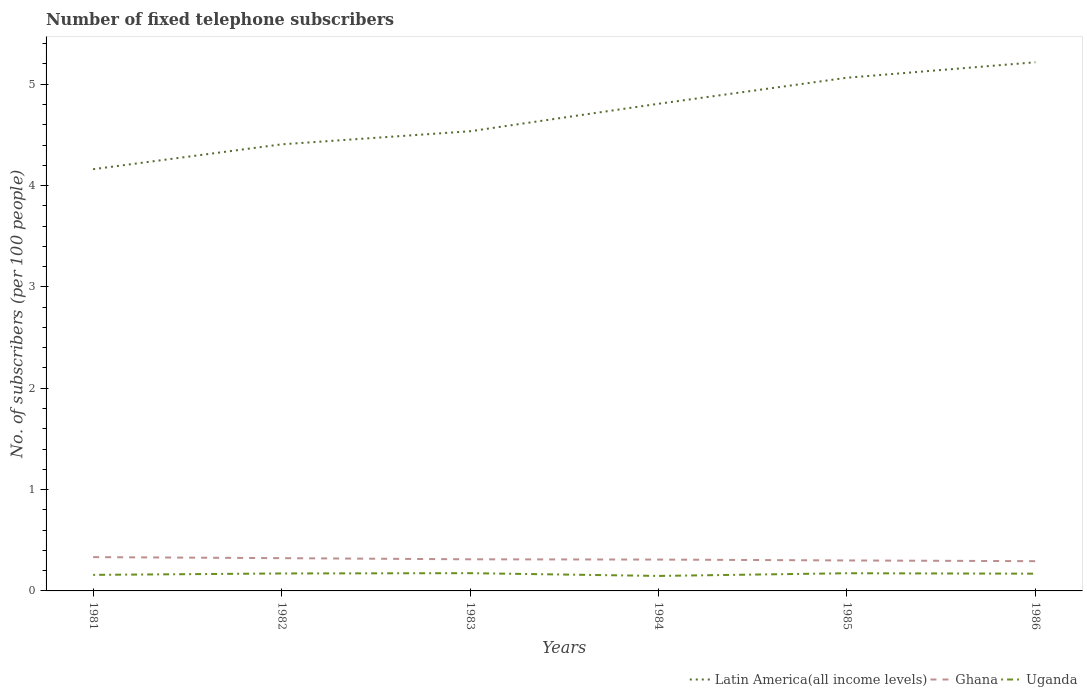Across all years, what is the maximum number of fixed telephone subscribers in Ghana?
Offer a very short reply. 0.29. In which year was the number of fixed telephone subscribers in Ghana maximum?
Make the answer very short. 1986. What is the total number of fixed telephone subscribers in Uganda in the graph?
Ensure brevity in your answer.  -0. What is the difference between the highest and the second highest number of fixed telephone subscribers in Ghana?
Offer a very short reply. 0.04. What is the difference between the highest and the lowest number of fixed telephone subscribers in Uganda?
Your response must be concise. 4. Is the number of fixed telephone subscribers in Ghana strictly greater than the number of fixed telephone subscribers in Latin America(all income levels) over the years?
Keep it short and to the point. Yes. Are the values on the major ticks of Y-axis written in scientific E-notation?
Ensure brevity in your answer.  No. Where does the legend appear in the graph?
Your answer should be compact. Bottom right. How many legend labels are there?
Offer a terse response. 3. What is the title of the graph?
Offer a terse response. Number of fixed telephone subscribers. What is the label or title of the Y-axis?
Make the answer very short. No. of subscribers (per 100 people). What is the No. of subscribers (per 100 people) in Latin America(all income levels) in 1981?
Keep it short and to the point. 4.16. What is the No. of subscribers (per 100 people) in Ghana in 1981?
Make the answer very short. 0.33. What is the No. of subscribers (per 100 people) in Uganda in 1981?
Your answer should be compact. 0.16. What is the No. of subscribers (per 100 people) of Latin America(all income levels) in 1982?
Your response must be concise. 4.41. What is the No. of subscribers (per 100 people) of Ghana in 1982?
Ensure brevity in your answer.  0.32. What is the No. of subscribers (per 100 people) of Uganda in 1982?
Give a very brief answer. 0.17. What is the No. of subscribers (per 100 people) in Latin America(all income levels) in 1983?
Offer a terse response. 4.54. What is the No. of subscribers (per 100 people) in Ghana in 1983?
Offer a very short reply. 0.31. What is the No. of subscribers (per 100 people) of Uganda in 1983?
Offer a very short reply. 0.18. What is the No. of subscribers (per 100 people) in Latin America(all income levels) in 1984?
Your answer should be compact. 4.81. What is the No. of subscribers (per 100 people) of Ghana in 1984?
Offer a very short reply. 0.31. What is the No. of subscribers (per 100 people) of Uganda in 1984?
Offer a terse response. 0.15. What is the No. of subscribers (per 100 people) in Latin America(all income levels) in 1985?
Provide a short and direct response. 5.06. What is the No. of subscribers (per 100 people) of Ghana in 1985?
Provide a short and direct response. 0.3. What is the No. of subscribers (per 100 people) of Uganda in 1985?
Your response must be concise. 0.17. What is the No. of subscribers (per 100 people) in Latin America(all income levels) in 1986?
Provide a succinct answer. 5.22. What is the No. of subscribers (per 100 people) in Ghana in 1986?
Provide a succinct answer. 0.29. What is the No. of subscribers (per 100 people) in Uganda in 1986?
Provide a short and direct response. 0.17. Across all years, what is the maximum No. of subscribers (per 100 people) of Latin America(all income levels)?
Give a very brief answer. 5.22. Across all years, what is the maximum No. of subscribers (per 100 people) of Ghana?
Give a very brief answer. 0.33. Across all years, what is the maximum No. of subscribers (per 100 people) of Uganda?
Your answer should be very brief. 0.18. Across all years, what is the minimum No. of subscribers (per 100 people) of Latin America(all income levels)?
Your response must be concise. 4.16. Across all years, what is the minimum No. of subscribers (per 100 people) of Ghana?
Your answer should be compact. 0.29. Across all years, what is the minimum No. of subscribers (per 100 people) in Uganda?
Offer a terse response. 0.15. What is the total No. of subscribers (per 100 people) of Latin America(all income levels) in the graph?
Ensure brevity in your answer.  28.19. What is the total No. of subscribers (per 100 people) in Ghana in the graph?
Your answer should be very brief. 1.87. What is the total No. of subscribers (per 100 people) in Uganda in the graph?
Ensure brevity in your answer.  1. What is the difference between the No. of subscribers (per 100 people) of Latin America(all income levels) in 1981 and that in 1982?
Your response must be concise. -0.25. What is the difference between the No. of subscribers (per 100 people) of Ghana in 1981 and that in 1982?
Provide a succinct answer. 0.01. What is the difference between the No. of subscribers (per 100 people) of Uganda in 1981 and that in 1982?
Your answer should be compact. -0.01. What is the difference between the No. of subscribers (per 100 people) of Latin America(all income levels) in 1981 and that in 1983?
Offer a terse response. -0.37. What is the difference between the No. of subscribers (per 100 people) of Ghana in 1981 and that in 1983?
Ensure brevity in your answer.  0.02. What is the difference between the No. of subscribers (per 100 people) of Uganda in 1981 and that in 1983?
Give a very brief answer. -0.02. What is the difference between the No. of subscribers (per 100 people) of Latin America(all income levels) in 1981 and that in 1984?
Provide a succinct answer. -0.65. What is the difference between the No. of subscribers (per 100 people) in Ghana in 1981 and that in 1984?
Provide a short and direct response. 0.02. What is the difference between the No. of subscribers (per 100 people) in Uganda in 1981 and that in 1984?
Provide a succinct answer. 0.01. What is the difference between the No. of subscribers (per 100 people) in Latin America(all income levels) in 1981 and that in 1985?
Provide a succinct answer. -0.9. What is the difference between the No. of subscribers (per 100 people) in Ghana in 1981 and that in 1985?
Give a very brief answer. 0.03. What is the difference between the No. of subscribers (per 100 people) of Uganda in 1981 and that in 1985?
Make the answer very short. -0.02. What is the difference between the No. of subscribers (per 100 people) of Latin America(all income levels) in 1981 and that in 1986?
Provide a short and direct response. -1.06. What is the difference between the No. of subscribers (per 100 people) of Ghana in 1981 and that in 1986?
Give a very brief answer. 0.04. What is the difference between the No. of subscribers (per 100 people) of Uganda in 1981 and that in 1986?
Provide a short and direct response. -0.01. What is the difference between the No. of subscribers (per 100 people) in Latin America(all income levels) in 1982 and that in 1983?
Your answer should be very brief. -0.13. What is the difference between the No. of subscribers (per 100 people) of Ghana in 1982 and that in 1983?
Provide a succinct answer. 0.01. What is the difference between the No. of subscribers (per 100 people) of Uganda in 1982 and that in 1983?
Make the answer very short. -0. What is the difference between the No. of subscribers (per 100 people) of Latin America(all income levels) in 1982 and that in 1984?
Your response must be concise. -0.4. What is the difference between the No. of subscribers (per 100 people) of Ghana in 1982 and that in 1984?
Offer a terse response. 0.01. What is the difference between the No. of subscribers (per 100 people) in Uganda in 1982 and that in 1984?
Ensure brevity in your answer.  0.02. What is the difference between the No. of subscribers (per 100 people) of Latin America(all income levels) in 1982 and that in 1985?
Provide a short and direct response. -0.66. What is the difference between the No. of subscribers (per 100 people) in Ghana in 1982 and that in 1985?
Keep it short and to the point. 0.02. What is the difference between the No. of subscribers (per 100 people) of Uganda in 1982 and that in 1985?
Ensure brevity in your answer.  -0. What is the difference between the No. of subscribers (per 100 people) in Latin America(all income levels) in 1982 and that in 1986?
Your answer should be very brief. -0.81. What is the difference between the No. of subscribers (per 100 people) of Ghana in 1982 and that in 1986?
Your answer should be very brief. 0.03. What is the difference between the No. of subscribers (per 100 people) in Uganda in 1982 and that in 1986?
Your answer should be very brief. 0. What is the difference between the No. of subscribers (per 100 people) of Latin America(all income levels) in 1983 and that in 1984?
Give a very brief answer. -0.27. What is the difference between the No. of subscribers (per 100 people) of Ghana in 1983 and that in 1984?
Offer a terse response. 0. What is the difference between the No. of subscribers (per 100 people) of Uganda in 1983 and that in 1984?
Offer a terse response. 0.03. What is the difference between the No. of subscribers (per 100 people) of Latin America(all income levels) in 1983 and that in 1985?
Your answer should be very brief. -0.53. What is the difference between the No. of subscribers (per 100 people) of Ghana in 1983 and that in 1985?
Your answer should be very brief. 0.01. What is the difference between the No. of subscribers (per 100 people) of Uganda in 1983 and that in 1985?
Provide a short and direct response. 0. What is the difference between the No. of subscribers (per 100 people) of Latin America(all income levels) in 1983 and that in 1986?
Ensure brevity in your answer.  -0.68. What is the difference between the No. of subscribers (per 100 people) of Ghana in 1983 and that in 1986?
Provide a short and direct response. 0.02. What is the difference between the No. of subscribers (per 100 people) of Uganda in 1983 and that in 1986?
Offer a very short reply. 0.01. What is the difference between the No. of subscribers (per 100 people) in Latin America(all income levels) in 1984 and that in 1985?
Make the answer very short. -0.26. What is the difference between the No. of subscribers (per 100 people) in Ghana in 1984 and that in 1985?
Give a very brief answer. 0.01. What is the difference between the No. of subscribers (per 100 people) in Uganda in 1984 and that in 1985?
Offer a terse response. -0.03. What is the difference between the No. of subscribers (per 100 people) in Latin America(all income levels) in 1984 and that in 1986?
Provide a short and direct response. -0.41. What is the difference between the No. of subscribers (per 100 people) of Ghana in 1984 and that in 1986?
Offer a very short reply. 0.02. What is the difference between the No. of subscribers (per 100 people) of Uganda in 1984 and that in 1986?
Offer a terse response. -0.02. What is the difference between the No. of subscribers (per 100 people) of Latin America(all income levels) in 1985 and that in 1986?
Keep it short and to the point. -0.15. What is the difference between the No. of subscribers (per 100 people) of Ghana in 1985 and that in 1986?
Offer a terse response. 0.01. What is the difference between the No. of subscribers (per 100 people) of Uganda in 1985 and that in 1986?
Your response must be concise. 0. What is the difference between the No. of subscribers (per 100 people) in Latin America(all income levels) in 1981 and the No. of subscribers (per 100 people) in Ghana in 1982?
Your answer should be compact. 3.84. What is the difference between the No. of subscribers (per 100 people) of Latin America(all income levels) in 1981 and the No. of subscribers (per 100 people) of Uganda in 1982?
Your answer should be compact. 3.99. What is the difference between the No. of subscribers (per 100 people) in Ghana in 1981 and the No. of subscribers (per 100 people) in Uganda in 1982?
Make the answer very short. 0.16. What is the difference between the No. of subscribers (per 100 people) in Latin America(all income levels) in 1981 and the No. of subscribers (per 100 people) in Ghana in 1983?
Keep it short and to the point. 3.85. What is the difference between the No. of subscribers (per 100 people) in Latin America(all income levels) in 1981 and the No. of subscribers (per 100 people) in Uganda in 1983?
Your answer should be very brief. 3.99. What is the difference between the No. of subscribers (per 100 people) of Ghana in 1981 and the No. of subscribers (per 100 people) of Uganda in 1983?
Provide a short and direct response. 0.16. What is the difference between the No. of subscribers (per 100 people) of Latin America(all income levels) in 1981 and the No. of subscribers (per 100 people) of Ghana in 1984?
Your answer should be very brief. 3.85. What is the difference between the No. of subscribers (per 100 people) of Latin America(all income levels) in 1981 and the No. of subscribers (per 100 people) of Uganda in 1984?
Offer a terse response. 4.01. What is the difference between the No. of subscribers (per 100 people) of Ghana in 1981 and the No. of subscribers (per 100 people) of Uganda in 1984?
Your answer should be very brief. 0.19. What is the difference between the No. of subscribers (per 100 people) in Latin America(all income levels) in 1981 and the No. of subscribers (per 100 people) in Ghana in 1985?
Your answer should be compact. 3.86. What is the difference between the No. of subscribers (per 100 people) of Latin America(all income levels) in 1981 and the No. of subscribers (per 100 people) of Uganda in 1985?
Your answer should be very brief. 3.99. What is the difference between the No. of subscribers (per 100 people) of Ghana in 1981 and the No. of subscribers (per 100 people) of Uganda in 1985?
Give a very brief answer. 0.16. What is the difference between the No. of subscribers (per 100 people) in Latin America(all income levels) in 1981 and the No. of subscribers (per 100 people) in Ghana in 1986?
Ensure brevity in your answer.  3.87. What is the difference between the No. of subscribers (per 100 people) in Latin America(all income levels) in 1981 and the No. of subscribers (per 100 people) in Uganda in 1986?
Give a very brief answer. 3.99. What is the difference between the No. of subscribers (per 100 people) of Ghana in 1981 and the No. of subscribers (per 100 people) of Uganda in 1986?
Keep it short and to the point. 0.16. What is the difference between the No. of subscribers (per 100 people) in Latin America(all income levels) in 1982 and the No. of subscribers (per 100 people) in Ghana in 1983?
Keep it short and to the point. 4.09. What is the difference between the No. of subscribers (per 100 people) of Latin America(all income levels) in 1982 and the No. of subscribers (per 100 people) of Uganda in 1983?
Your response must be concise. 4.23. What is the difference between the No. of subscribers (per 100 people) of Ghana in 1982 and the No. of subscribers (per 100 people) of Uganda in 1983?
Offer a very short reply. 0.15. What is the difference between the No. of subscribers (per 100 people) in Latin America(all income levels) in 1982 and the No. of subscribers (per 100 people) in Ghana in 1984?
Offer a terse response. 4.1. What is the difference between the No. of subscribers (per 100 people) of Latin America(all income levels) in 1982 and the No. of subscribers (per 100 people) of Uganda in 1984?
Give a very brief answer. 4.26. What is the difference between the No. of subscribers (per 100 people) in Ghana in 1982 and the No. of subscribers (per 100 people) in Uganda in 1984?
Offer a very short reply. 0.18. What is the difference between the No. of subscribers (per 100 people) of Latin America(all income levels) in 1982 and the No. of subscribers (per 100 people) of Ghana in 1985?
Offer a terse response. 4.11. What is the difference between the No. of subscribers (per 100 people) of Latin America(all income levels) in 1982 and the No. of subscribers (per 100 people) of Uganda in 1985?
Keep it short and to the point. 4.23. What is the difference between the No. of subscribers (per 100 people) of Ghana in 1982 and the No. of subscribers (per 100 people) of Uganda in 1985?
Provide a short and direct response. 0.15. What is the difference between the No. of subscribers (per 100 people) of Latin America(all income levels) in 1982 and the No. of subscribers (per 100 people) of Ghana in 1986?
Your response must be concise. 4.11. What is the difference between the No. of subscribers (per 100 people) of Latin America(all income levels) in 1982 and the No. of subscribers (per 100 people) of Uganda in 1986?
Your response must be concise. 4.24. What is the difference between the No. of subscribers (per 100 people) in Ghana in 1982 and the No. of subscribers (per 100 people) in Uganda in 1986?
Make the answer very short. 0.15. What is the difference between the No. of subscribers (per 100 people) of Latin America(all income levels) in 1983 and the No. of subscribers (per 100 people) of Ghana in 1984?
Give a very brief answer. 4.23. What is the difference between the No. of subscribers (per 100 people) in Latin America(all income levels) in 1983 and the No. of subscribers (per 100 people) in Uganda in 1984?
Provide a short and direct response. 4.39. What is the difference between the No. of subscribers (per 100 people) in Ghana in 1983 and the No. of subscribers (per 100 people) in Uganda in 1984?
Keep it short and to the point. 0.16. What is the difference between the No. of subscribers (per 100 people) of Latin America(all income levels) in 1983 and the No. of subscribers (per 100 people) of Ghana in 1985?
Provide a short and direct response. 4.24. What is the difference between the No. of subscribers (per 100 people) in Latin America(all income levels) in 1983 and the No. of subscribers (per 100 people) in Uganda in 1985?
Give a very brief answer. 4.36. What is the difference between the No. of subscribers (per 100 people) of Ghana in 1983 and the No. of subscribers (per 100 people) of Uganda in 1985?
Ensure brevity in your answer.  0.14. What is the difference between the No. of subscribers (per 100 people) of Latin America(all income levels) in 1983 and the No. of subscribers (per 100 people) of Ghana in 1986?
Your answer should be compact. 4.24. What is the difference between the No. of subscribers (per 100 people) in Latin America(all income levels) in 1983 and the No. of subscribers (per 100 people) in Uganda in 1986?
Offer a terse response. 4.37. What is the difference between the No. of subscribers (per 100 people) in Ghana in 1983 and the No. of subscribers (per 100 people) in Uganda in 1986?
Make the answer very short. 0.14. What is the difference between the No. of subscribers (per 100 people) in Latin America(all income levels) in 1984 and the No. of subscribers (per 100 people) in Ghana in 1985?
Make the answer very short. 4.51. What is the difference between the No. of subscribers (per 100 people) of Latin America(all income levels) in 1984 and the No. of subscribers (per 100 people) of Uganda in 1985?
Give a very brief answer. 4.63. What is the difference between the No. of subscribers (per 100 people) of Ghana in 1984 and the No. of subscribers (per 100 people) of Uganda in 1985?
Offer a terse response. 0.14. What is the difference between the No. of subscribers (per 100 people) of Latin America(all income levels) in 1984 and the No. of subscribers (per 100 people) of Ghana in 1986?
Your answer should be very brief. 4.51. What is the difference between the No. of subscribers (per 100 people) in Latin America(all income levels) in 1984 and the No. of subscribers (per 100 people) in Uganda in 1986?
Keep it short and to the point. 4.64. What is the difference between the No. of subscribers (per 100 people) in Ghana in 1984 and the No. of subscribers (per 100 people) in Uganda in 1986?
Keep it short and to the point. 0.14. What is the difference between the No. of subscribers (per 100 people) in Latin America(all income levels) in 1985 and the No. of subscribers (per 100 people) in Ghana in 1986?
Keep it short and to the point. 4.77. What is the difference between the No. of subscribers (per 100 people) of Latin America(all income levels) in 1985 and the No. of subscribers (per 100 people) of Uganda in 1986?
Ensure brevity in your answer.  4.89. What is the difference between the No. of subscribers (per 100 people) of Ghana in 1985 and the No. of subscribers (per 100 people) of Uganda in 1986?
Keep it short and to the point. 0.13. What is the average No. of subscribers (per 100 people) in Latin America(all income levels) per year?
Your response must be concise. 4.7. What is the average No. of subscribers (per 100 people) in Ghana per year?
Your response must be concise. 0.31. What is the average No. of subscribers (per 100 people) of Uganda per year?
Provide a succinct answer. 0.17. In the year 1981, what is the difference between the No. of subscribers (per 100 people) of Latin America(all income levels) and No. of subscribers (per 100 people) of Ghana?
Your answer should be very brief. 3.83. In the year 1981, what is the difference between the No. of subscribers (per 100 people) in Latin America(all income levels) and No. of subscribers (per 100 people) in Uganda?
Keep it short and to the point. 4. In the year 1981, what is the difference between the No. of subscribers (per 100 people) in Ghana and No. of subscribers (per 100 people) in Uganda?
Your answer should be compact. 0.18. In the year 1982, what is the difference between the No. of subscribers (per 100 people) of Latin America(all income levels) and No. of subscribers (per 100 people) of Ghana?
Your response must be concise. 4.08. In the year 1982, what is the difference between the No. of subscribers (per 100 people) of Latin America(all income levels) and No. of subscribers (per 100 people) of Uganda?
Ensure brevity in your answer.  4.23. In the year 1982, what is the difference between the No. of subscribers (per 100 people) of Ghana and No. of subscribers (per 100 people) of Uganda?
Offer a terse response. 0.15. In the year 1983, what is the difference between the No. of subscribers (per 100 people) of Latin America(all income levels) and No. of subscribers (per 100 people) of Ghana?
Provide a succinct answer. 4.22. In the year 1983, what is the difference between the No. of subscribers (per 100 people) in Latin America(all income levels) and No. of subscribers (per 100 people) in Uganda?
Give a very brief answer. 4.36. In the year 1983, what is the difference between the No. of subscribers (per 100 people) of Ghana and No. of subscribers (per 100 people) of Uganda?
Provide a short and direct response. 0.14. In the year 1984, what is the difference between the No. of subscribers (per 100 people) in Latin America(all income levels) and No. of subscribers (per 100 people) in Ghana?
Keep it short and to the point. 4.5. In the year 1984, what is the difference between the No. of subscribers (per 100 people) of Latin America(all income levels) and No. of subscribers (per 100 people) of Uganda?
Provide a short and direct response. 4.66. In the year 1984, what is the difference between the No. of subscribers (per 100 people) in Ghana and No. of subscribers (per 100 people) in Uganda?
Offer a very short reply. 0.16. In the year 1985, what is the difference between the No. of subscribers (per 100 people) in Latin America(all income levels) and No. of subscribers (per 100 people) in Ghana?
Offer a very short reply. 4.76. In the year 1985, what is the difference between the No. of subscribers (per 100 people) of Latin America(all income levels) and No. of subscribers (per 100 people) of Uganda?
Offer a very short reply. 4.89. In the year 1985, what is the difference between the No. of subscribers (per 100 people) in Ghana and No. of subscribers (per 100 people) in Uganda?
Make the answer very short. 0.13. In the year 1986, what is the difference between the No. of subscribers (per 100 people) of Latin America(all income levels) and No. of subscribers (per 100 people) of Ghana?
Ensure brevity in your answer.  4.92. In the year 1986, what is the difference between the No. of subscribers (per 100 people) of Latin America(all income levels) and No. of subscribers (per 100 people) of Uganda?
Your answer should be very brief. 5.05. In the year 1986, what is the difference between the No. of subscribers (per 100 people) of Ghana and No. of subscribers (per 100 people) of Uganda?
Offer a very short reply. 0.12. What is the ratio of the No. of subscribers (per 100 people) of Latin America(all income levels) in 1981 to that in 1982?
Offer a terse response. 0.94. What is the ratio of the No. of subscribers (per 100 people) of Ghana in 1981 to that in 1982?
Ensure brevity in your answer.  1.03. What is the ratio of the No. of subscribers (per 100 people) in Uganda in 1981 to that in 1982?
Give a very brief answer. 0.92. What is the ratio of the No. of subscribers (per 100 people) in Latin America(all income levels) in 1981 to that in 1983?
Offer a terse response. 0.92. What is the ratio of the No. of subscribers (per 100 people) of Ghana in 1981 to that in 1983?
Your answer should be compact. 1.07. What is the ratio of the No. of subscribers (per 100 people) in Uganda in 1981 to that in 1983?
Give a very brief answer. 0.9. What is the ratio of the No. of subscribers (per 100 people) in Latin America(all income levels) in 1981 to that in 1984?
Your answer should be compact. 0.87. What is the ratio of the No. of subscribers (per 100 people) of Ghana in 1981 to that in 1984?
Offer a terse response. 1.08. What is the ratio of the No. of subscribers (per 100 people) of Uganda in 1981 to that in 1984?
Make the answer very short. 1.07. What is the ratio of the No. of subscribers (per 100 people) of Latin America(all income levels) in 1981 to that in 1985?
Keep it short and to the point. 0.82. What is the ratio of the No. of subscribers (per 100 people) of Ghana in 1981 to that in 1985?
Keep it short and to the point. 1.11. What is the ratio of the No. of subscribers (per 100 people) of Uganda in 1981 to that in 1985?
Provide a succinct answer. 0.91. What is the ratio of the No. of subscribers (per 100 people) in Latin America(all income levels) in 1981 to that in 1986?
Keep it short and to the point. 0.8. What is the ratio of the No. of subscribers (per 100 people) of Ghana in 1981 to that in 1986?
Your answer should be very brief. 1.14. What is the ratio of the No. of subscribers (per 100 people) in Uganda in 1981 to that in 1986?
Make the answer very short. 0.93. What is the ratio of the No. of subscribers (per 100 people) in Latin America(all income levels) in 1982 to that in 1983?
Keep it short and to the point. 0.97. What is the ratio of the No. of subscribers (per 100 people) in Ghana in 1982 to that in 1983?
Make the answer very short. 1.04. What is the ratio of the No. of subscribers (per 100 people) of Uganda in 1982 to that in 1983?
Make the answer very short. 0.98. What is the ratio of the No. of subscribers (per 100 people) in Latin America(all income levels) in 1982 to that in 1984?
Your response must be concise. 0.92. What is the ratio of the No. of subscribers (per 100 people) in Ghana in 1982 to that in 1984?
Ensure brevity in your answer.  1.04. What is the ratio of the No. of subscribers (per 100 people) in Uganda in 1982 to that in 1984?
Make the answer very short. 1.17. What is the ratio of the No. of subscribers (per 100 people) in Latin America(all income levels) in 1982 to that in 1985?
Offer a terse response. 0.87. What is the ratio of the No. of subscribers (per 100 people) of Ghana in 1982 to that in 1985?
Give a very brief answer. 1.08. What is the ratio of the No. of subscribers (per 100 people) in Uganda in 1982 to that in 1985?
Your answer should be compact. 0.99. What is the ratio of the No. of subscribers (per 100 people) in Latin America(all income levels) in 1982 to that in 1986?
Your response must be concise. 0.84. What is the ratio of the No. of subscribers (per 100 people) of Ghana in 1982 to that in 1986?
Provide a succinct answer. 1.1. What is the ratio of the No. of subscribers (per 100 people) of Uganda in 1982 to that in 1986?
Your answer should be very brief. 1.01. What is the ratio of the No. of subscribers (per 100 people) of Latin America(all income levels) in 1983 to that in 1984?
Provide a succinct answer. 0.94. What is the ratio of the No. of subscribers (per 100 people) of Ghana in 1983 to that in 1984?
Offer a very short reply. 1.01. What is the ratio of the No. of subscribers (per 100 people) of Uganda in 1983 to that in 1984?
Give a very brief answer. 1.18. What is the ratio of the No. of subscribers (per 100 people) in Latin America(all income levels) in 1983 to that in 1985?
Offer a very short reply. 0.9. What is the ratio of the No. of subscribers (per 100 people) in Ghana in 1983 to that in 1985?
Offer a terse response. 1.04. What is the ratio of the No. of subscribers (per 100 people) of Latin America(all income levels) in 1983 to that in 1986?
Make the answer very short. 0.87. What is the ratio of the No. of subscribers (per 100 people) in Ghana in 1983 to that in 1986?
Ensure brevity in your answer.  1.06. What is the ratio of the No. of subscribers (per 100 people) of Uganda in 1983 to that in 1986?
Your response must be concise. 1.03. What is the ratio of the No. of subscribers (per 100 people) of Latin America(all income levels) in 1984 to that in 1985?
Give a very brief answer. 0.95. What is the ratio of the No. of subscribers (per 100 people) of Ghana in 1984 to that in 1985?
Provide a succinct answer. 1.03. What is the ratio of the No. of subscribers (per 100 people) of Uganda in 1984 to that in 1985?
Provide a succinct answer. 0.85. What is the ratio of the No. of subscribers (per 100 people) in Latin America(all income levels) in 1984 to that in 1986?
Make the answer very short. 0.92. What is the ratio of the No. of subscribers (per 100 people) in Ghana in 1984 to that in 1986?
Your answer should be very brief. 1.05. What is the ratio of the No. of subscribers (per 100 people) of Uganda in 1984 to that in 1986?
Your response must be concise. 0.87. What is the ratio of the No. of subscribers (per 100 people) in Latin America(all income levels) in 1985 to that in 1986?
Give a very brief answer. 0.97. What is the ratio of the No. of subscribers (per 100 people) of Ghana in 1985 to that in 1986?
Provide a succinct answer. 1.02. What is the ratio of the No. of subscribers (per 100 people) in Uganda in 1985 to that in 1986?
Keep it short and to the point. 1.03. What is the difference between the highest and the second highest No. of subscribers (per 100 people) of Latin America(all income levels)?
Offer a terse response. 0.15. What is the difference between the highest and the second highest No. of subscribers (per 100 people) in Ghana?
Your answer should be very brief. 0.01. What is the difference between the highest and the second highest No. of subscribers (per 100 people) of Uganda?
Make the answer very short. 0. What is the difference between the highest and the lowest No. of subscribers (per 100 people) in Latin America(all income levels)?
Your answer should be very brief. 1.06. What is the difference between the highest and the lowest No. of subscribers (per 100 people) in Ghana?
Provide a succinct answer. 0.04. What is the difference between the highest and the lowest No. of subscribers (per 100 people) in Uganda?
Offer a very short reply. 0.03. 